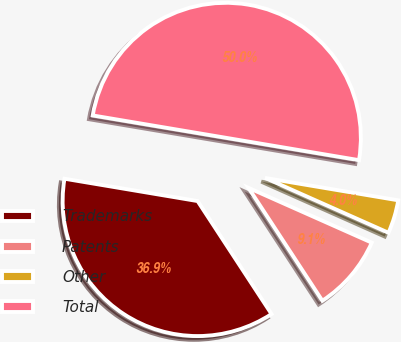<chart> <loc_0><loc_0><loc_500><loc_500><pie_chart><fcel>Trademarks<fcel>Patents<fcel>Other<fcel>Total<nl><fcel>36.87%<fcel>9.12%<fcel>4.01%<fcel>50.0%<nl></chart> 